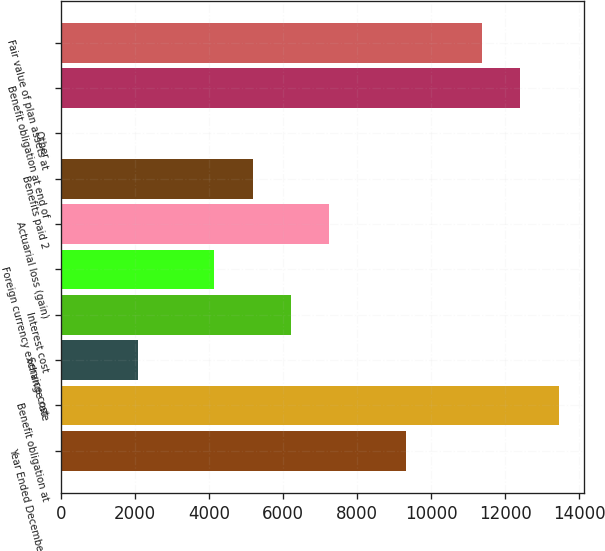Convert chart to OTSL. <chart><loc_0><loc_0><loc_500><loc_500><bar_chart><fcel>Year Ended December 31<fcel>Benefit obligation at<fcel>Service cost<fcel>Interest cost<fcel>Foreign currency exchange rate<fcel>Actuarial loss (gain)<fcel>Benefits paid 2<fcel>Other<fcel>Benefit obligation at end of<fcel>Fair value of plan assets at<nl><fcel>9311.5<fcel>13449.5<fcel>2070<fcel>6208<fcel>4139<fcel>7242.5<fcel>5173.5<fcel>1<fcel>12415<fcel>11380.5<nl></chart> 